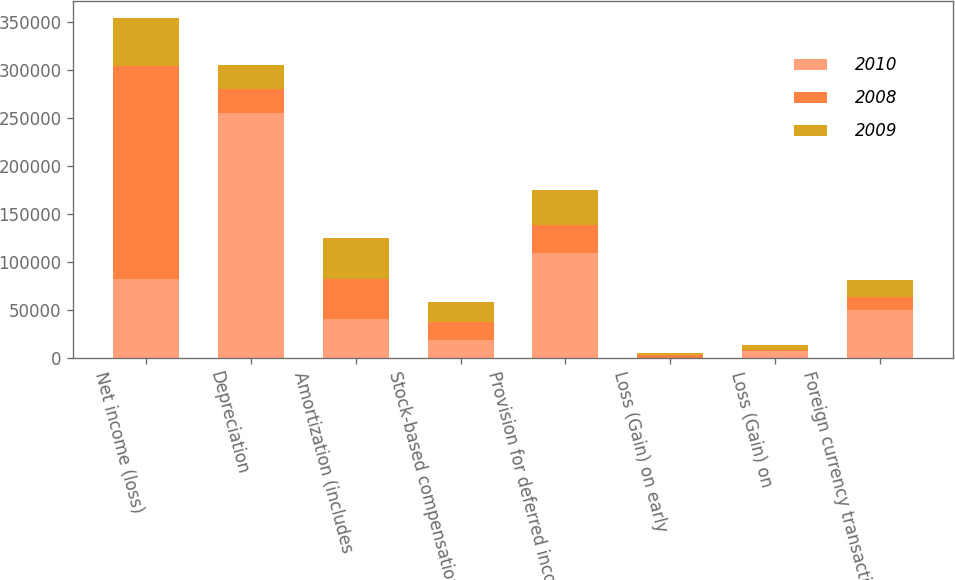Convert chart to OTSL. <chart><loc_0><loc_0><loc_500><loc_500><stacked_bar_chart><ecel><fcel>Net income (loss)<fcel>Depreciation<fcel>Amortization (includes<fcel>Stock-based compensation<fcel>Provision for deferred income<fcel>Loss (Gain) on early<fcel>Loss (Gain) on<fcel>Foreign currency transactions<nl><fcel>2010<fcel>81943<fcel>254619<fcel>41101<fcel>18988<fcel>109109<fcel>418<fcel>7483<fcel>50312<nl><fcel>2008<fcel>222306<fcel>25050.5<fcel>40618<fcel>18703<fcel>29723<fcel>3031<fcel>406<fcel>12686<nl><fcel>2009<fcel>48992<fcel>25050.5<fcel>42970<fcel>20378<fcel>35674<fcel>1792<fcel>6143<fcel>18105<nl></chart> 